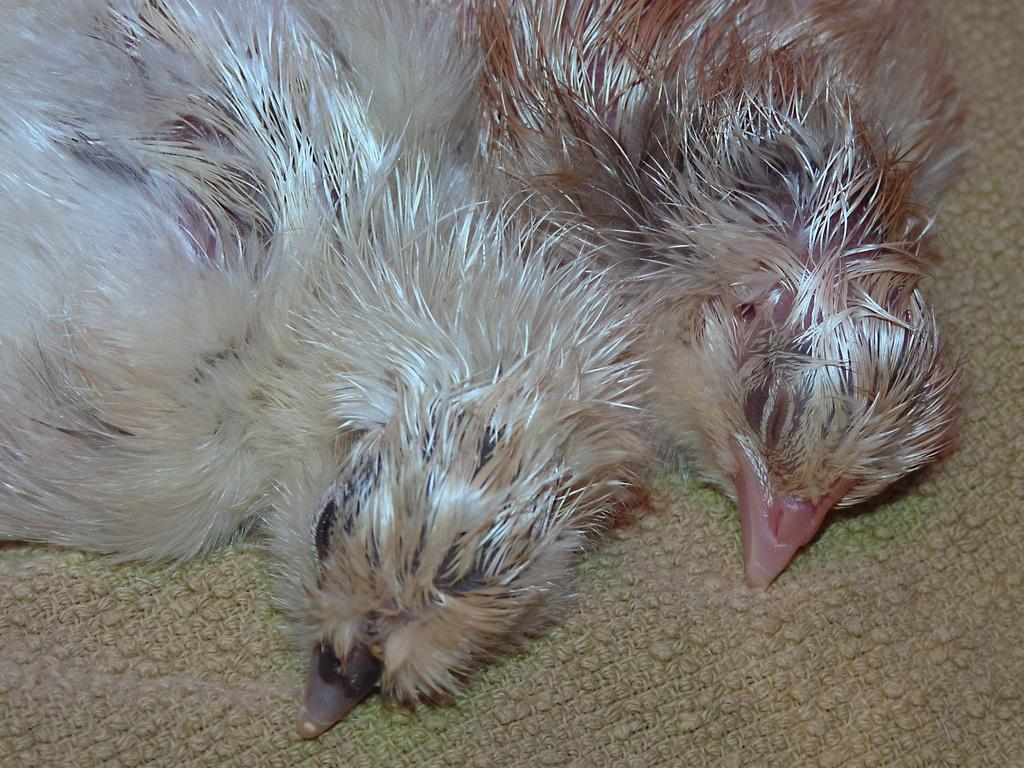How many birds are present in the image? There are two birds in the image. What are the birds resting on? The birds are lying on a cloth. Can you see any dinosaurs playing with tomatoes on the seashore in the image? No, there are no dinosaurs, tomatoes, or seashore present in the image; it only features two birds lying on a cloth. 